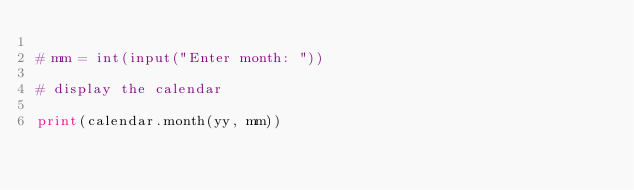<code> <loc_0><loc_0><loc_500><loc_500><_Python_>
# mm = int(input("Enter month: "))

# display the calendar

print(calendar.month(yy, mm))
</code> 